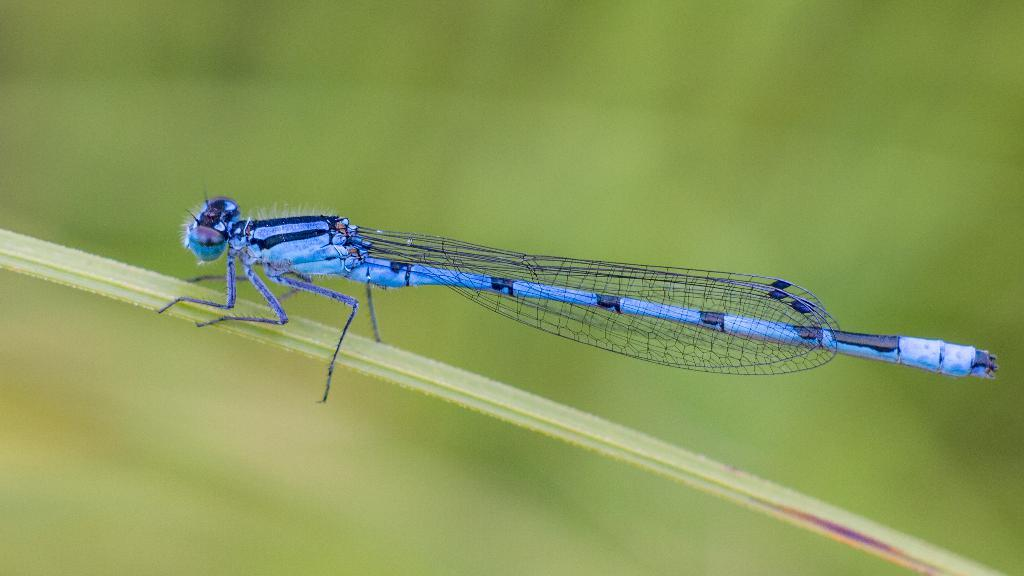What type of insect is in the image? There is a dragonfly in the image. What colors can be seen on the dragonfly? The dragonfly has black and blue colors. Where is the dragonfly located in the image? The dragonfly is on a leaf. How would you describe the background of the image? The background of the image is blurred. What type of fan is visible in the image? There is no fan present in the image. What form does the dragonfly take in the image? The dragonfly is in its natural insect form in the image. 